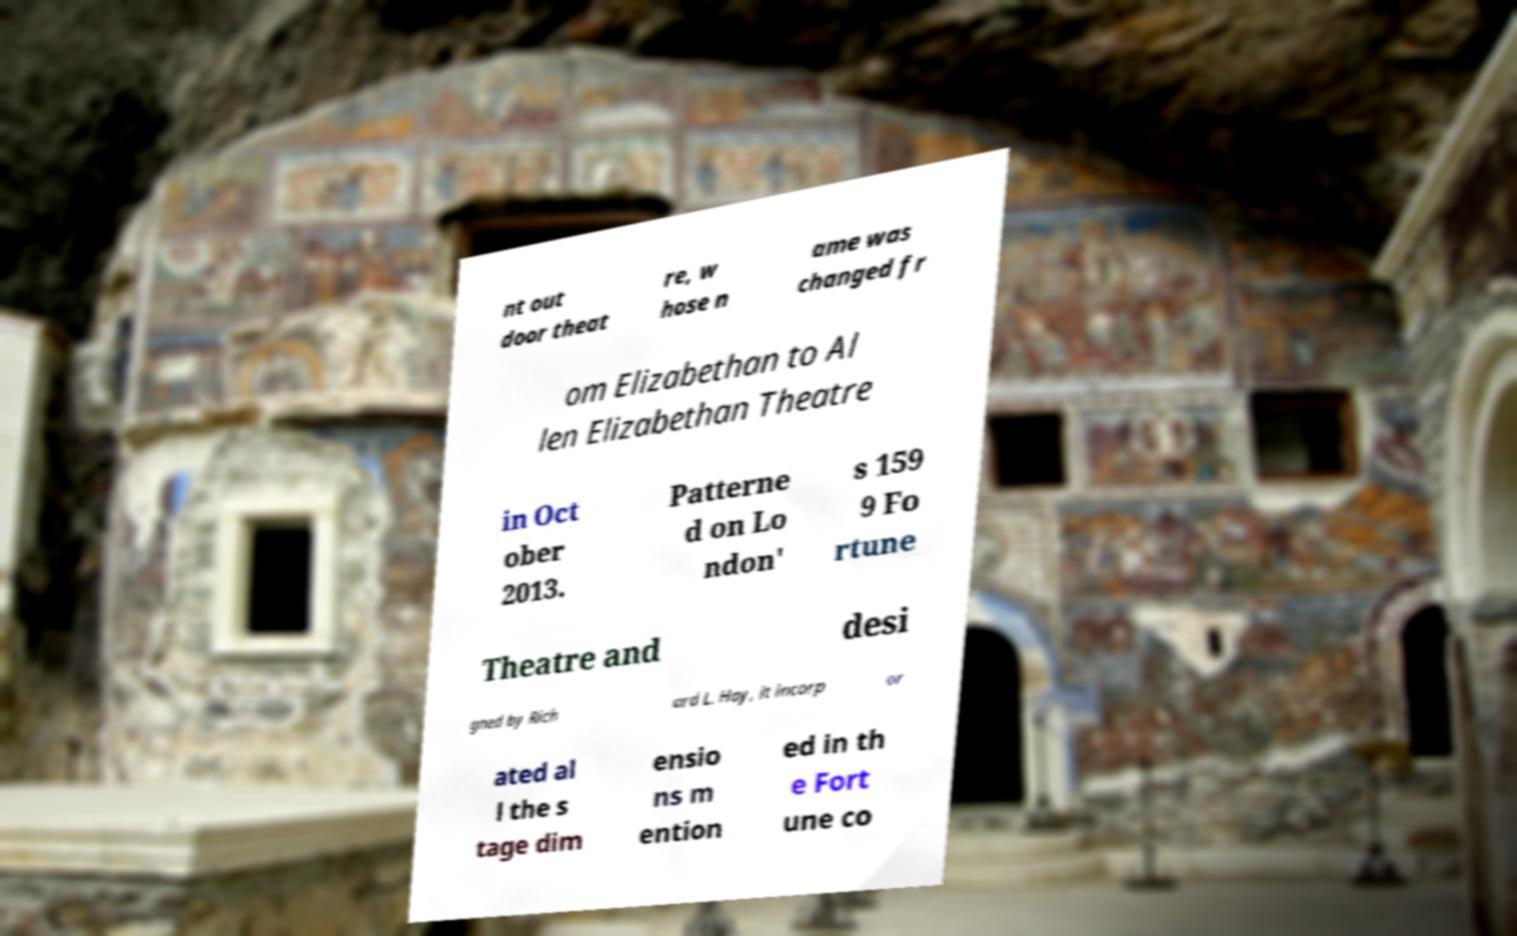Please read and relay the text visible in this image. What does it say? nt out door theat re, w hose n ame was changed fr om Elizabethan to Al len Elizabethan Theatre in Oct ober 2013. Patterne d on Lo ndon' s 159 9 Fo rtune Theatre and desi gned by Rich ard L. Hay, it incorp or ated al l the s tage dim ensio ns m ention ed in th e Fort une co 